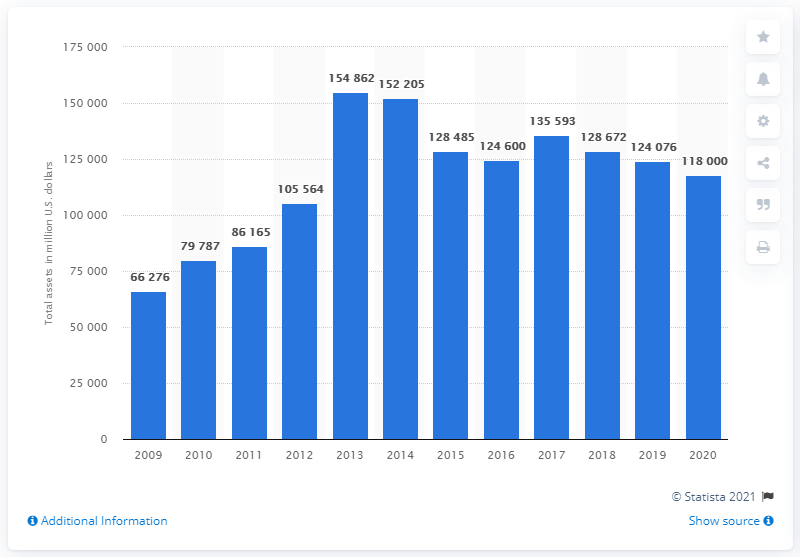Give some essential details in this illustration. At the end of the fiscal year 2020, Glencore's total assets were approximately 118,000. Glencore's total assets at the end of the fiscal year 2020 were approximately 118,000. 